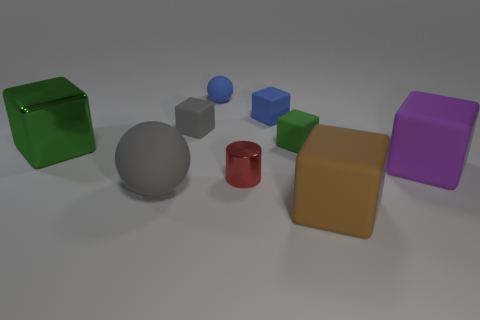There is a small ball; is it the same color as the cube behind the small gray rubber cube?
Keep it short and to the point. Yes. How many big objects are right of the metallic object that is to the left of the small blue rubber sphere?
Give a very brief answer. 3. There is a rubber thing that is in front of the large purple object and on the right side of the blue matte block; what is its size?
Provide a succinct answer. Large. Are there any green matte things of the same size as the gray rubber block?
Your answer should be compact. Yes. Are there more tiny gray cubes that are to the left of the metal cylinder than large objects that are behind the tiny green thing?
Keep it short and to the point. Yes. Do the gray sphere and the tiny cylinder that is to the left of the brown matte thing have the same material?
Your response must be concise. No. There is a tiny blue rubber thing on the right side of the ball to the right of the gray ball; how many blue matte blocks are to the left of it?
Your answer should be very brief. 0. There is a big brown object; is it the same shape as the matte object behind the tiny blue rubber block?
Provide a succinct answer. No. What is the color of the large object that is behind the large sphere and to the right of the tiny cylinder?
Give a very brief answer. Purple. There is a small cube to the left of the tiny blue rubber sphere to the right of the large matte thing left of the small gray thing; what is it made of?
Provide a succinct answer. Rubber. 